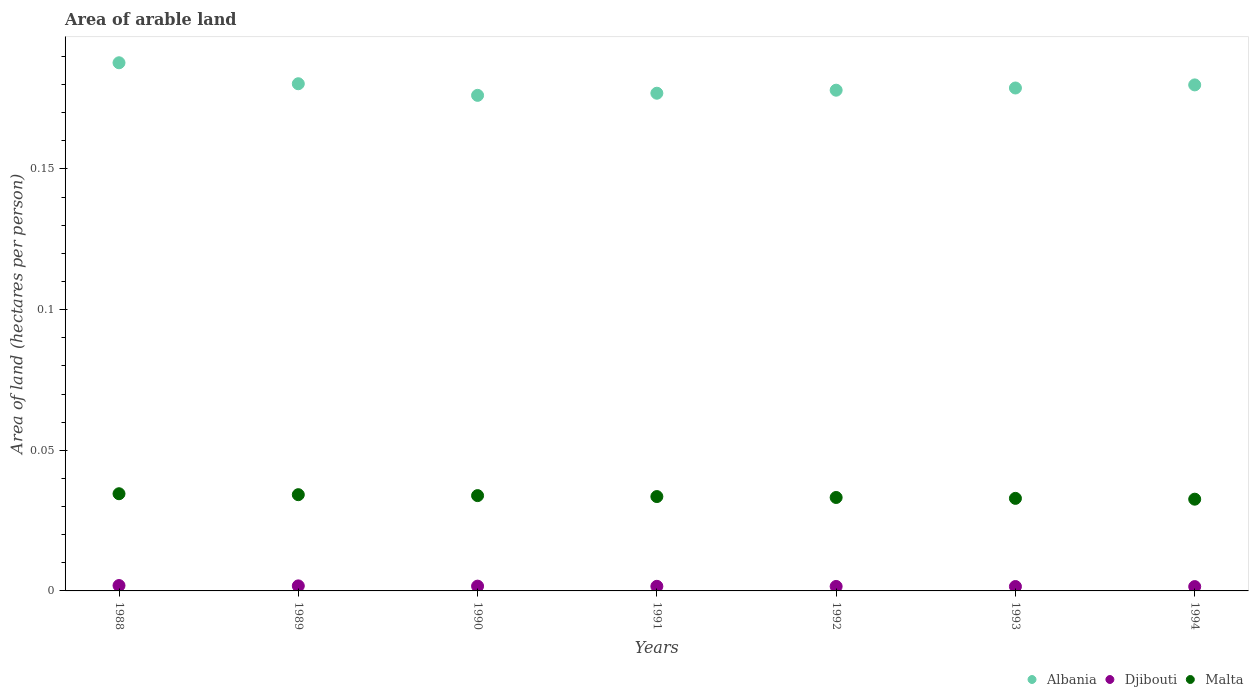What is the total arable land in Malta in 1988?
Offer a very short reply. 0.03. Across all years, what is the maximum total arable land in Malta?
Your answer should be very brief. 0.03. Across all years, what is the minimum total arable land in Albania?
Offer a very short reply. 0.18. In which year was the total arable land in Albania minimum?
Offer a very short reply. 1990. What is the total total arable land in Djibouti in the graph?
Your answer should be very brief. 0.01. What is the difference between the total arable land in Malta in 1991 and that in 1994?
Ensure brevity in your answer.  0. What is the difference between the total arable land in Albania in 1994 and the total arable land in Malta in 1990?
Give a very brief answer. 0.15. What is the average total arable land in Albania per year?
Make the answer very short. 0.18. In the year 1994, what is the difference between the total arable land in Malta and total arable land in Albania?
Your response must be concise. -0.15. What is the ratio of the total arable land in Malta in 1989 to that in 1991?
Keep it short and to the point. 1.02. What is the difference between the highest and the second highest total arable land in Djibouti?
Give a very brief answer. 0. What is the difference between the highest and the lowest total arable land in Albania?
Ensure brevity in your answer.  0.01. Is it the case that in every year, the sum of the total arable land in Djibouti and total arable land in Albania  is greater than the total arable land in Malta?
Ensure brevity in your answer.  Yes. Does the total arable land in Malta monotonically increase over the years?
Your response must be concise. No. Is the total arable land in Albania strictly greater than the total arable land in Djibouti over the years?
Provide a succinct answer. Yes. How many dotlines are there?
Provide a short and direct response. 3. What is the difference between two consecutive major ticks on the Y-axis?
Ensure brevity in your answer.  0.05. Are the values on the major ticks of Y-axis written in scientific E-notation?
Provide a succinct answer. No. Does the graph contain grids?
Your response must be concise. No. Where does the legend appear in the graph?
Make the answer very short. Bottom right. What is the title of the graph?
Provide a succinct answer. Area of arable land. Does "Hong Kong" appear as one of the legend labels in the graph?
Your answer should be very brief. No. What is the label or title of the X-axis?
Keep it short and to the point. Years. What is the label or title of the Y-axis?
Your answer should be compact. Area of land (hectares per person). What is the Area of land (hectares per person) of Albania in 1988?
Provide a succinct answer. 0.19. What is the Area of land (hectares per person) of Djibouti in 1988?
Provide a succinct answer. 0. What is the Area of land (hectares per person) of Malta in 1988?
Provide a succinct answer. 0.03. What is the Area of land (hectares per person) of Albania in 1989?
Keep it short and to the point. 0.18. What is the Area of land (hectares per person) in Djibouti in 1989?
Your response must be concise. 0. What is the Area of land (hectares per person) of Malta in 1989?
Give a very brief answer. 0.03. What is the Area of land (hectares per person) of Albania in 1990?
Make the answer very short. 0.18. What is the Area of land (hectares per person) of Djibouti in 1990?
Offer a very short reply. 0. What is the Area of land (hectares per person) of Malta in 1990?
Your answer should be very brief. 0.03. What is the Area of land (hectares per person) of Albania in 1991?
Make the answer very short. 0.18. What is the Area of land (hectares per person) of Djibouti in 1991?
Keep it short and to the point. 0. What is the Area of land (hectares per person) of Malta in 1991?
Your answer should be compact. 0.03. What is the Area of land (hectares per person) of Albania in 1992?
Offer a very short reply. 0.18. What is the Area of land (hectares per person) in Djibouti in 1992?
Your answer should be compact. 0. What is the Area of land (hectares per person) of Malta in 1992?
Offer a terse response. 0.03. What is the Area of land (hectares per person) in Albania in 1993?
Offer a very short reply. 0.18. What is the Area of land (hectares per person) of Djibouti in 1993?
Your response must be concise. 0. What is the Area of land (hectares per person) in Malta in 1993?
Your response must be concise. 0.03. What is the Area of land (hectares per person) of Albania in 1994?
Offer a very short reply. 0.18. What is the Area of land (hectares per person) in Djibouti in 1994?
Offer a terse response. 0. What is the Area of land (hectares per person) of Malta in 1994?
Offer a very short reply. 0.03. Across all years, what is the maximum Area of land (hectares per person) of Albania?
Your response must be concise. 0.19. Across all years, what is the maximum Area of land (hectares per person) in Djibouti?
Your response must be concise. 0. Across all years, what is the maximum Area of land (hectares per person) of Malta?
Keep it short and to the point. 0.03. Across all years, what is the minimum Area of land (hectares per person) in Albania?
Provide a short and direct response. 0.18. Across all years, what is the minimum Area of land (hectares per person) of Djibouti?
Offer a terse response. 0. Across all years, what is the minimum Area of land (hectares per person) in Malta?
Ensure brevity in your answer.  0.03. What is the total Area of land (hectares per person) in Albania in the graph?
Provide a short and direct response. 1.26. What is the total Area of land (hectares per person) in Djibouti in the graph?
Make the answer very short. 0.01. What is the total Area of land (hectares per person) in Malta in the graph?
Keep it short and to the point. 0.23. What is the difference between the Area of land (hectares per person) in Albania in 1988 and that in 1989?
Offer a very short reply. 0.01. What is the difference between the Area of land (hectares per person) of Malta in 1988 and that in 1989?
Provide a short and direct response. 0. What is the difference between the Area of land (hectares per person) of Albania in 1988 and that in 1990?
Your answer should be very brief. 0.01. What is the difference between the Area of land (hectares per person) in Djibouti in 1988 and that in 1990?
Provide a short and direct response. 0. What is the difference between the Area of land (hectares per person) of Malta in 1988 and that in 1990?
Provide a succinct answer. 0. What is the difference between the Area of land (hectares per person) of Albania in 1988 and that in 1991?
Your answer should be very brief. 0.01. What is the difference between the Area of land (hectares per person) in Djibouti in 1988 and that in 1991?
Keep it short and to the point. 0. What is the difference between the Area of land (hectares per person) in Albania in 1988 and that in 1992?
Provide a succinct answer. 0.01. What is the difference between the Area of land (hectares per person) of Malta in 1988 and that in 1992?
Your answer should be very brief. 0. What is the difference between the Area of land (hectares per person) of Albania in 1988 and that in 1993?
Give a very brief answer. 0.01. What is the difference between the Area of land (hectares per person) of Malta in 1988 and that in 1993?
Your answer should be compact. 0. What is the difference between the Area of land (hectares per person) of Albania in 1988 and that in 1994?
Your response must be concise. 0.01. What is the difference between the Area of land (hectares per person) of Djibouti in 1988 and that in 1994?
Your response must be concise. 0. What is the difference between the Area of land (hectares per person) of Malta in 1988 and that in 1994?
Provide a succinct answer. 0. What is the difference between the Area of land (hectares per person) in Albania in 1989 and that in 1990?
Offer a very short reply. 0. What is the difference between the Area of land (hectares per person) in Albania in 1989 and that in 1991?
Your answer should be compact. 0. What is the difference between the Area of land (hectares per person) in Malta in 1989 and that in 1991?
Provide a succinct answer. 0. What is the difference between the Area of land (hectares per person) of Albania in 1989 and that in 1992?
Your answer should be compact. 0. What is the difference between the Area of land (hectares per person) in Djibouti in 1989 and that in 1992?
Ensure brevity in your answer.  0. What is the difference between the Area of land (hectares per person) of Malta in 1989 and that in 1992?
Keep it short and to the point. 0. What is the difference between the Area of land (hectares per person) of Albania in 1989 and that in 1993?
Offer a terse response. 0. What is the difference between the Area of land (hectares per person) of Malta in 1989 and that in 1993?
Keep it short and to the point. 0. What is the difference between the Area of land (hectares per person) of Albania in 1989 and that in 1994?
Offer a very short reply. 0. What is the difference between the Area of land (hectares per person) in Djibouti in 1989 and that in 1994?
Provide a short and direct response. 0. What is the difference between the Area of land (hectares per person) of Malta in 1989 and that in 1994?
Ensure brevity in your answer.  0. What is the difference between the Area of land (hectares per person) of Albania in 1990 and that in 1991?
Provide a short and direct response. -0. What is the difference between the Area of land (hectares per person) in Malta in 1990 and that in 1991?
Offer a very short reply. 0. What is the difference between the Area of land (hectares per person) in Albania in 1990 and that in 1992?
Provide a succinct answer. -0. What is the difference between the Area of land (hectares per person) in Malta in 1990 and that in 1992?
Offer a terse response. 0. What is the difference between the Area of land (hectares per person) in Albania in 1990 and that in 1993?
Make the answer very short. -0. What is the difference between the Area of land (hectares per person) of Djibouti in 1990 and that in 1993?
Provide a short and direct response. 0. What is the difference between the Area of land (hectares per person) in Albania in 1990 and that in 1994?
Your answer should be compact. -0. What is the difference between the Area of land (hectares per person) of Djibouti in 1990 and that in 1994?
Provide a succinct answer. 0. What is the difference between the Area of land (hectares per person) in Malta in 1990 and that in 1994?
Your answer should be compact. 0. What is the difference between the Area of land (hectares per person) in Albania in 1991 and that in 1992?
Provide a succinct answer. -0. What is the difference between the Area of land (hectares per person) in Djibouti in 1991 and that in 1992?
Keep it short and to the point. 0. What is the difference between the Area of land (hectares per person) in Albania in 1991 and that in 1993?
Your answer should be very brief. -0. What is the difference between the Area of land (hectares per person) in Malta in 1991 and that in 1993?
Your answer should be compact. 0. What is the difference between the Area of land (hectares per person) in Albania in 1991 and that in 1994?
Make the answer very short. -0. What is the difference between the Area of land (hectares per person) of Malta in 1991 and that in 1994?
Your response must be concise. 0. What is the difference between the Area of land (hectares per person) of Albania in 1992 and that in 1993?
Offer a very short reply. -0. What is the difference between the Area of land (hectares per person) of Djibouti in 1992 and that in 1993?
Ensure brevity in your answer.  0. What is the difference between the Area of land (hectares per person) of Albania in 1992 and that in 1994?
Your answer should be compact. -0. What is the difference between the Area of land (hectares per person) of Djibouti in 1992 and that in 1994?
Offer a terse response. 0. What is the difference between the Area of land (hectares per person) in Malta in 1992 and that in 1994?
Ensure brevity in your answer.  0. What is the difference between the Area of land (hectares per person) of Albania in 1993 and that in 1994?
Offer a very short reply. -0. What is the difference between the Area of land (hectares per person) in Djibouti in 1993 and that in 1994?
Your answer should be very brief. 0. What is the difference between the Area of land (hectares per person) in Albania in 1988 and the Area of land (hectares per person) in Djibouti in 1989?
Provide a succinct answer. 0.19. What is the difference between the Area of land (hectares per person) in Albania in 1988 and the Area of land (hectares per person) in Malta in 1989?
Your answer should be compact. 0.15. What is the difference between the Area of land (hectares per person) of Djibouti in 1988 and the Area of land (hectares per person) of Malta in 1989?
Make the answer very short. -0.03. What is the difference between the Area of land (hectares per person) in Albania in 1988 and the Area of land (hectares per person) in Djibouti in 1990?
Your answer should be compact. 0.19. What is the difference between the Area of land (hectares per person) in Albania in 1988 and the Area of land (hectares per person) in Malta in 1990?
Offer a terse response. 0.15. What is the difference between the Area of land (hectares per person) of Djibouti in 1988 and the Area of land (hectares per person) of Malta in 1990?
Your answer should be compact. -0.03. What is the difference between the Area of land (hectares per person) in Albania in 1988 and the Area of land (hectares per person) in Djibouti in 1991?
Offer a terse response. 0.19. What is the difference between the Area of land (hectares per person) of Albania in 1988 and the Area of land (hectares per person) of Malta in 1991?
Provide a succinct answer. 0.15. What is the difference between the Area of land (hectares per person) of Djibouti in 1988 and the Area of land (hectares per person) of Malta in 1991?
Provide a short and direct response. -0.03. What is the difference between the Area of land (hectares per person) in Albania in 1988 and the Area of land (hectares per person) in Djibouti in 1992?
Your answer should be very brief. 0.19. What is the difference between the Area of land (hectares per person) in Albania in 1988 and the Area of land (hectares per person) in Malta in 1992?
Provide a succinct answer. 0.15. What is the difference between the Area of land (hectares per person) of Djibouti in 1988 and the Area of land (hectares per person) of Malta in 1992?
Ensure brevity in your answer.  -0.03. What is the difference between the Area of land (hectares per person) in Albania in 1988 and the Area of land (hectares per person) in Djibouti in 1993?
Your answer should be very brief. 0.19. What is the difference between the Area of land (hectares per person) of Albania in 1988 and the Area of land (hectares per person) of Malta in 1993?
Your answer should be compact. 0.15. What is the difference between the Area of land (hectares per person) of Djibouti in 1988 and the Area of land (hectares per person) of Malta in 1993?
Provide a succinct answer. -0.03. What is the difference between the Area of land (hectares per person) in Albania in 1988 and the Area of land (hectares per person) in Djibouti in 1994?
Keep it short and to the point. 0.19. What is the difference between the Area of land (hectares per person) of Albania in 1988 and the Area of land (hectares per person) of Malta in 1994?
Your response must be concise. 0.16. What is the difference between the Area of land (hectares per person) in Djibouti in 1988 and the Area of land (hectares per person) in Malta in 1994?
Your answer should be very brief. -0.03. What is the difference between the Area of land (hectares per person) in Albania in 1989 and the Area of land (hectares per person) in Djibouti in 1990?
Offer a very short reply. 0.18. What is the difference between the Area of land (hectares per person) in Albania in 1989 and the Area of land (hectares per person) in Malta in 1990?
Your response must be concise. 0.15. What is the difference between the Area of land (hectares per person) of Djibouti in 1989 and the Area of land (hectares per person) of Malta in 1990?
Offer a terse response. -0.03. What is the difference between the Area of land (hectares per person) of Albania in 1989 and the Area of land (hectares per person) of Djibouti in 1991?
Provide a succinct answer. 0.18. What is the difference between the Area of land (hectares per person) in Albania in 1989 and the Area of land (hectares per person) in Malta in 1991?
Provide a short and direct response. 0.15. What is the difference between the Area of land (hectares per person) in Djibouti in 1989 and the Area of land (hectares per person) in Malta in 1991?
Your response must be concise. -0.03. What is the difference between the Area of land (hectares per person) of Albania in 1989 and the Area of land (hectares per person) of Djibouti in 1992?
Make the answer very short. 0.18. What is the difference between the Area of land (hectares per person) of Albania in 1989 and the Area of land (hectares per person) of Malta in 1992?
Your response must be concise. 0.15. What is the difference between the Area of land (hectares per person) in Djibouti in 1989 and the Area of land (hectares per person) in Malta in 1992?
Keep it short and to the point. -0.03. What is the difference between the Area of land (hectares per person) of Albania in 1989 and the Area of land (hectares per person) of Djibouti in 1993?
Give a very brief answer. 0.18. What is the difference between the Area of land (hectares per person) in Albania in 1989 and the Area of land (hectares per person) in Malta in 1993?
Your answer should be compact. 0.15. What is the difference between the Area of land (hectares per person) of Djibouti in 1989 and the Area of land (hectares per person) of Malta in 1993?
Ensure brevity in your answer.  -0.03. What is the difference between the Area of land (hectares per person) in Albania in 1989 and the Area of land (hectares per person) in Djibouti in 1994?
Provide a succinct answer. 0.18. What is the difference between the Area of land (hectares per person) in Albania in 1989 and the Area of land (hectares per person) in Malta in 1994?
Make the answer very short. 0.15. What is the difference between the Area of land (hectares per person) of Djibouti in 1989 and the Area of land (hectares per person) of Malta in 1994?
Your response must be concise. -0.03. What is the difference between the Area of land (hectares per person) of Albania in 1990 and the Area of land (hectares per person) of Djibouti in 1991?
Offer a terse response. 0.17. What is the difference between the Area of land (hectares per person) of Albania in 1990 and the Area of land (hectares per person) of Malta in 1991?
Your response must be concise. 0.14. What is the difference between the Area of land (hectares per person) of Djibouti in 1990 and the Area of land (hectares per person) of Malta in 1991?
Provide a short and direct response. -0.03. What is the difference between the Area of land (hectares per person) of Albania in 1990 and the Area of land (hectares per person) of Djibouti in 1992?
Give a very brief answer. 0.17. What is the difference between the Area of land (hectares per person) in Albania in 1990 and the Area of land (hectares per person) in Malta in 1992?
Your answer should be very brief. 0.14. What is the difference between the Area of land (hectares per person) of Djibouti in 1990 and the Area of land (hectares per person) of Malta in 1992?
Offer a very short reply. -0.03. What is the difference between the Area of land (hectares per person) of Albania in 1990 and the Area of land (hectares per person) of Djibouti in 1993?
Your response must be concise. 0.17. What is the difference between the Area of land (hectares per person) in Albania in 1990 and the Area of land (hectares per person) in Malta in 1993?
Make the answer very short. 0.14. What is the difference between the Area of land (hectares per person) in Djibouti in 1990 and the Area of land (hectares per person) in Malta in 1993?
Your answer should be very brief. -0.03. What is the difference between the Area of land (hectares per person) of Albania in 1990 and the Area of land (hectares per person) of Djibouti in 1994?
Offer a terse response. 0.17. What is the difference between the Area of land (hectares per person) in Albania in 1990 and the Area of land (hectares per person) in Malta in 1994?
Make the answer very short. 0.14. What is the difference between the Area of land (hectares per person) in Djibouti in 1990 and the Area of land (hectares per person) in Malta in 1994?
Your answer should be compact. -0.03. What is the difference between the Area of land (hectares per person) in Albania in 1991 and the Area of land (hectares per person) in Djibouti in 1992?
Offer a terse response. 0.18. What is the difference between the Area of land (hectares per person) in Albania in 1991 and the Area of land (hectares per person) in Malta in 1992?
Offer a very short reply. 0.14. What is the difference between the Area of land (hectares per person) of Djibouti in 1991 and the Area of land (hectares per person) of Malta in 1992?
Your response must be concise. -0.03. What is the difference between the Area of land (hectares per person) of Albania in 1991 and the Area of land (hectares per person) of Djibouti in 1993?
Your response must be concise. 0.18. What is the difference between the Area of land (hectares per person) in Albania in 1991 and the Area of land (hectares per person) in Malta in 1993?
Your answer should be very brief. 0.14. What is the difference between the Area of land (hectares per person) of Djibouti in 1991 and the Area of land (hectares per person) of Malta in 1993?
Keep it short and to the point. -0.03. What is the difference between the Area of land (hectares per person) in Albania in 1991 and the Area of land (hectares per person) in Djibouti in 1994?
Your response must be concise. 0.18. What is the difference between the Area of land (hectares per person) of Albania in 1991 and the Area of land (hectares per person) of Malta in 1994?
Offer a terse response. 0.14. What is the difference between the Area of land (hectares per person) in Djibouti in 1991 and the Area of land (hectares per person) in Malta in 1994?
Provide a succinct answer. -0.03. What is the difference between the Area of land (hectares per person) in Albania in 1992 and the Area of land (hectares per person) in Djibouti in 1993?
Give a very brief answer. 0.18. What is the difference between the Area of land (hectares per person) in Albania in 1992 and the Area of land (hectares per person) in Malta in 1993?
Your answer should be very brief. 0.15. What is the difference between the Area of land (hectares per person) in Djibouti in 1992 and the Area of land (hectares per person) in Malta in 1993?
Make the answer very short. -0.03. What is the difference between the Area of land (hectares per person) in Albania in 1992 and the Area of land (hectares per person) in Djibouti in 1994?
Give a very brief answer. 0.18. What is the difference between the Area of land (hectares per person) of Albania in 1992 and the Area of land (hectares per person) of Malta in 1994?
Your answer should be compact. 0.15. What is the difference between the Area of land (hectares per person) of Djibouti in 1992 and the Area of land (hectares per person) of Malta in 1994?
Provide a short and direct response. -0.03. What is the difference between the Area of land (hectares per person) in Albania in 1993 and the Area of land (hectares per person) in Djibouti in 1994?
Offer a very short reply. 0.18. What is the difference between the Area of land (hectares per person) of Albania in 1993 and the Area of land (hectares per person) of Malta in 1994?
Give a very brief answer. 0.15. What is the difference between the Area of land (hectares per person) in Djibouti in 1993 and the Area of land (hectares per person) in Malta in 1994?
Ensure brevity in your answer.  -0.03. What is the average Area of land (hectares per person) in Albania per year?
Offer a terse response. 0.18. What is the average Area of land (hectares per person) in Djibouti per year?
Your answer should be compact. 0. What is the average Area of land (hectares per person) in Malta per year?
Offer a very short reply. 0.03. In the year 1988, what is the difference between the Area of land (hectares per person) in Albania and Area of land (hectares per person) in Djibouti?
Offer a very short reply. 0.19. In the year 1988, what is the difference between the Area of land (hectares per person) in Albania and Area of land (hectares per person) in Malta?
Keep it short and to the point. 0.15. In the year 1988, what is the difference between the Area of land (hectares per person) of Djibouti and Area of land (hectares per person) of Malta?
Your answer should be very brief. -0.03. In the year 1989, what is the difference between the Area of land (hectares per person) of Albania and Area of land (hectares per person) of Djibouti?
Make the answer very short. 0.18. In the year 1989, what is the difference between the Area of land (hectares per person) in Albania and Area of land (hectares per person) in Malta?
Offer a terse response. 0.15. In the year 1989, what is the difference between the Area of land (hectares per person) of Djibouti and Area of land (hectares per person) of Malta?
Give a very brief answer. -0.03. In the year 1990, what is the difference between the Area of land (hectares per person) of Albania and Area of land (hectares per person) of Djibouti?
Ensure brevity in your answer.  0.17. In the year 1990, what is the difference between the Area of land (hectares per person) in Albania and Area of land (hectares per person) in Malta?
Offer a very short reply. 0.14. In the year 1990, what is the difference between the Area of land (hectares per person) of Djibouti and Area of land (hectares per person) of Malta?
Keep it short and to the point. -0.03. In the year 1991, what is the difference between the Area of land (hectares per person) of Albania and Area of land (hectares per person) of Djibouti?
Ensure brevity in your answer.  0.18. In the year 1991, what is the difference between the Area of land (hectares per person) of Albania and Area of land (hectares per person) of Malta?
Ensure brevity in your answer.  0.14. In the year 1991, what is the difference between the Area of land (hectares per person) of Djibouti and Area of land (hectares per person) of Malta?
Your answer should be very brief. -0.03. In the year 1992, what is the difference between the Area of land (hectares per person) in Albania and Area of land (hectares per person) in Djibouti?
Provide a succinct answer. 0.18. In the year 1992, what is the difference between the Area of land (hectares per person) in Albania and Area of land (hectares per person) in Malta?
Provide a short and direct response. 0.14. In the year 1992, what is the difference between the Area of land (hectares per person) of Djibouti and Area of land (hectares per person) of Malta?
Make the answer very short. -0.03. In the year 1993, what is the difference between the Area of land (hectares per person) of Albania and Area of land (hectares per person) of Djibouti?
Your answer should be compact. 0.18. In the year 1993, what is the difference between the Area of land (hectares per person) in Albania and Area of land (hectares per person) in Malta?
Provide a short and direct response. 0.15. In the year 1993, what is the difference between the Area of land (hectares per person) of Djibouti and Area of land (hectares per person) of Malta?
Your answer should be very brief. -0.03. In the year 1994, what is the difference between the Area of land (hectares per person) in Albania and Area of land (hectares per person) in Djibouti?
Offer a very short reply. 0.18. In the year 1994, what is the difference between the Area of land (hectares per person) in Albania and Area of land (hectares per person) in Malta?
Provide a succinct answer. 0.15. In the year 1994, what is the difference between the Area of land (hectares per person) in Djibouti and Area of land (hectares per person) in Malta?
Ensure brevity in your answer.  -0.03. What is the ratio of the Area of land (hectares per person) of Albania in 1988 to that in 1989?
Offer a terse response. 1.04. What is the ratio of the Area of land (hectares per person) of Djibouti in 1988 to that in 1989?
Give a very brief answer. 1.07. What is the ratio of the Area of land (hectares per person) of Malta in 1988 to that in 1989?
Your answer should be very brief. 1.01. What is the ratio of the Area of land (hectares per person) of Albania in 1988 to that in 1990?
Give a very brief answer. 1.07. What is the ratio of the Area of land (hectares per person) in Djibouti in 1988 to that in 1990?
Your response must be concise. 1.12. What is the ratio of the Area of land (hectares per person) in Malta in 1988 to that in 1990?
Offer a very short reply. 1.02. What is the ratio of the Area of land (hectares per person) of Albania in 1988 to that in 1991?
Your response must be concise. 1.06. What is the ratio of the Area of land (hectares per person) of Djibouti in 1988 to that in 1991?
Provide a succinct answer. 1.17. What is the ratio of the Area of land (hectares per person) of Malta in 1988 to that in 1991?
Your answer should be very brief. 1.03. What is the ratio of the Area of land (hectares per person) of Albania in 1988 to that in 1992?
Make the answer very short. 1.05. What is the ratio of the Area of land (hectares per person) in Djibouti in 1988 to that in 1992?
Keep it short and to the point. 1.2. What is the ratio of the Area of land (hectares per person) of Malta in 1988 to that in 1992?
Your answer should be very brief. 1.04. What is the ratio of the Area of land (hectares per person) in Albania in 1988 to that in 1993?
Provide a succinct answer. 1.05. What is the ratio of the Area of land (hectares per person) in Djibouti in 1988 to that in 1993?
Offer a very short reply. 1.22. What is the ratio of the Area of land (hectares per person) of Malta in 1988 to that in 1993?
Your response must be concise. 1.05. What is the ratio of the Area of land (hectares per person) in Albania in 1988 to that in 1994?
Give a very brief answer. 1.04. What is the ratio of the Area of land (hectares per person) in Djibouti in 1988 to that in 1994?
Give a very brief answer. 1.24. What is the ratio of the Area of land (hectares per person) of Malta in 1988 to that in 1994?
Your answer should be very brief. 1.06. What is the ratio of the Area of land (hectares per person) of Albania in 1989 to that in 1990?
Your answer should be compact. 1.02. What is the ratio of the Area of land (hectares per person) of Djibouti in 1989 to that in 1990?
Ensure brevity in your answer.  1.05. What is the ratio of the Area of land (hectares per person) of Malta in 1989 to that in 1990?
Your answer should be very brief. 1.01. What is the ratio of the Area of land (hectares per person) in Albania in 1989 to that in 1991?
Give a very brief answer. 1.02. What is the ratio of the Area of land (hectares per person) of Djibouti in 1989 to that in 1991?
Your response must be concise. 1.09. What is the ratio of the Area of land (hectares per person) in Malta in 1989 to that in 1991?
Make the answer very short. 1.02. What is the ratio of the Area of land (hectares per person) of Albania in 1989 to that in 1992?
Your answer should be very brief. 1.01. What is the ratio of the Area of land (hectares per person) of Djibouti in 1989 to that in 1992?
Provide a succinct answer. 1.12. What is the ratio of the Area of land (hectares per person) of Malta in 1989 to that in 1992?
Your response must be concise. 1.03. What is the ratio of the Area of land (hectares per person) of Albania in 1989 to that in 1993?
Your answer should be compact. 1.01. What is the ratio of the Area of land (hectares per person) of Djibouti in 1989 to that in 1993?
Make the answer very short. 1.14. What is the ratio of the Area of land (hectares per person) in Malta in 1989 to that in 1993?
Give a very brief answer. 1.04. What is the ratio of the Area of land (hectares per person) of Djibouti in 1989 to that in 1994?
Offer a very short reply. 1.16. What is the ratio of the Area of land (hectares per person) of Malta in 1989 to that in 1994?
Your response must be concise. 1.05. What is the ratio of the Area of land (hectares per person) in Djibouti in 1990 to that in 1991?
Provide a succinct answer. 1.04. What is the ratio of the Area of land (hectares per person) in Albania in 1990 to that in 1992?
Offer a very short reply. 0.99. What is the ratio of the Area of land (hectares per person) of Djibouti in 1990 to that in 1992?
Give a very brief answer. 1.07. What is the ratio of the Area of land (hectares per person) of Malta in 1990 to that in 1992?
Your answer should be very brief. 1.02. What is the ratio of the Area of land (hectares per person) in Albania in 1990 to that in 1993?
Keep it short and to the point. 0.99. What is the ratio of the Area of land (hectares per person) of Djibouti in 1990 to that in 1993?
Offer a terse response. 1.09. What is the ratio of the Area of land (hectares per person) in Malta in 1990 to that in 1993?
Give a very brief answer. 1.03. What is the ratio of the Area of land (hectares per person) in Albania in 1990 to that in 1994?
Offer a very short reply. 0.98. What is the ratio of the Area of land (hectares per person) in Djibouti in 1990 to that in 1994?
Give a very brief answer. 1.1. What is the ratio of the Area of land (hectares per person) in Malta in 1990 to that in 1994?
Make the answer very short. 1.04. What is the ratio of the Area of land (hectares per person) in Albania in 1991 to that in 1992?
Offer a terse response. 0.99. What is the ratio of the Area of land (hectares per person) in Djibouti in 1991 to that in 1992?
Ensure brevity in your answer.  1.03. What is the ratio of the Area of land (hectares per person) of Malta in 1991 to that in 1992?
Provide a short and direct response. 1.01. What is the ratio of the Area of land (hectares per person) in Djibouti in 1991 to that in 1993?
Your response must be concise. 1.05. What is the ratio of the Area of land (hectares per person) of Malta in 1991 to that in 1993?
Your answer should be compact. 1.02. What is the ratio of the Area of land (hectares per person) of Albania in 1991 to that in 1994?
Your response must be concise. 0.98. What is the ratio of the Area of land (hectares per person) of Djibouti in 1991 to that in 1994?
Provide a short and direct response. 1.06. What is the ratio of the Area of land (hectares per person) of Malta in 1991 to that in 1994?
Make the answer very short. 1.03. What is the ratio of the Area of land (hectares per person) in Djibouti in 1992 to that in 1993?
Your answer should be very brief. 1.02. What is the ratio of the Area of land (hectares per person) of Malta in 1992 to that in 1993?
Provide a succinct answer. 1.01. What is the ratio of the Area of land (hectares per person) in Djibouti in 1992 to that in 1994?
Offer a terse response. 1.04. What is the ratio of the Area of land (hectares per person) in Malta in 1992 to that in 1994?
Offer a very short reply. 1.02. What is the ratio of the Area of land (hectares per person) of Albania in 1993 to that in 1994?
Offer a terse response. 0.99. What is the ratio of the Area of land (hectares per person) in Djibouti in 1993 to that in 1994?
Provide a short and direct response. 1.02. What is the ratio of the Area of land (hectares per person) of Malta in 1993 to that in 1994?
Your answer should be very brief. 1.01. What is the difference between the highest and the second highest Area of land (hectares per person) in Albania?
Offer a terse response. 0.01. What is the difference between the highest and the second highest Area of land (hectares per person) of Djibouti?
Make the answer very short. 0. What is the difference between the highest and the lowest Area of land (hectares per person) of Albania?
Your response must be concise. 0.01. What is the difference between the highest and the lowest Area of land (hectares per person) in Djibouti?
Give a very brief answer. 0. What is the difference between the highest and the lowest Area of land (hectares per person) in Malta?
Your answer should be very brief. 0. 